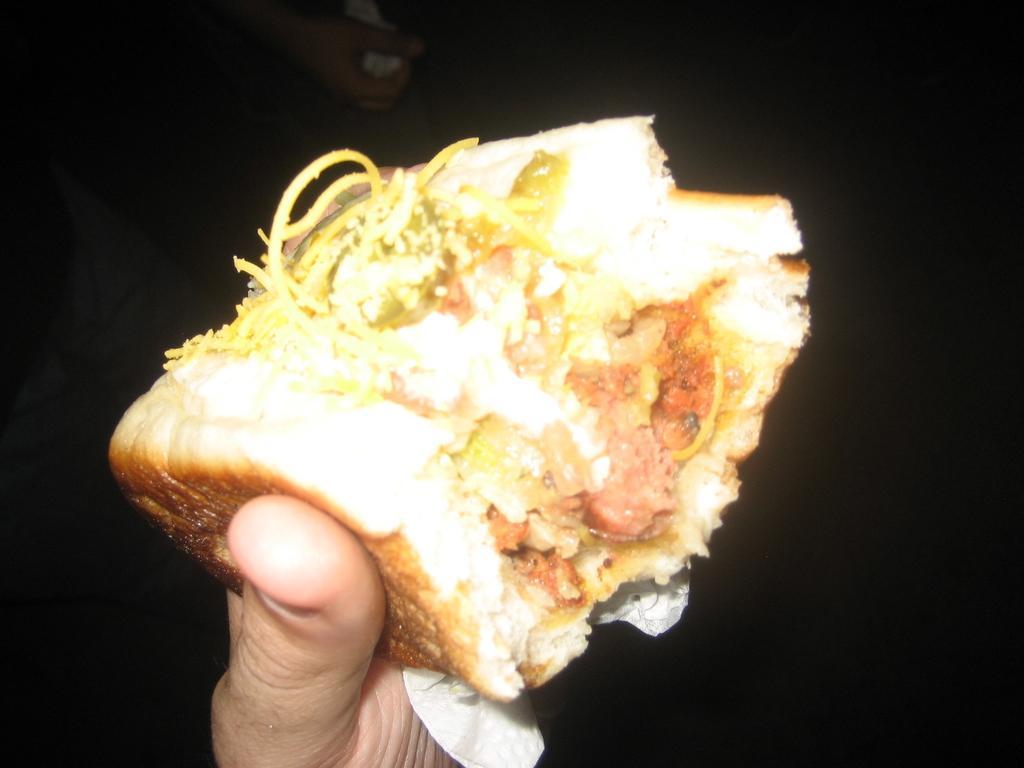Describe this image in one or two sentences. In this image we can see a person's hand holding some food item and the background is dark. 